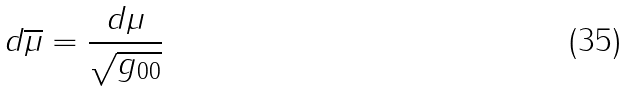<formula> <loc_0><loc_0><loc_500><loc_500>d \overline { \mu } = \frac { d \mu } { \sqrt { g _ { 0 0 } } }</formula> 